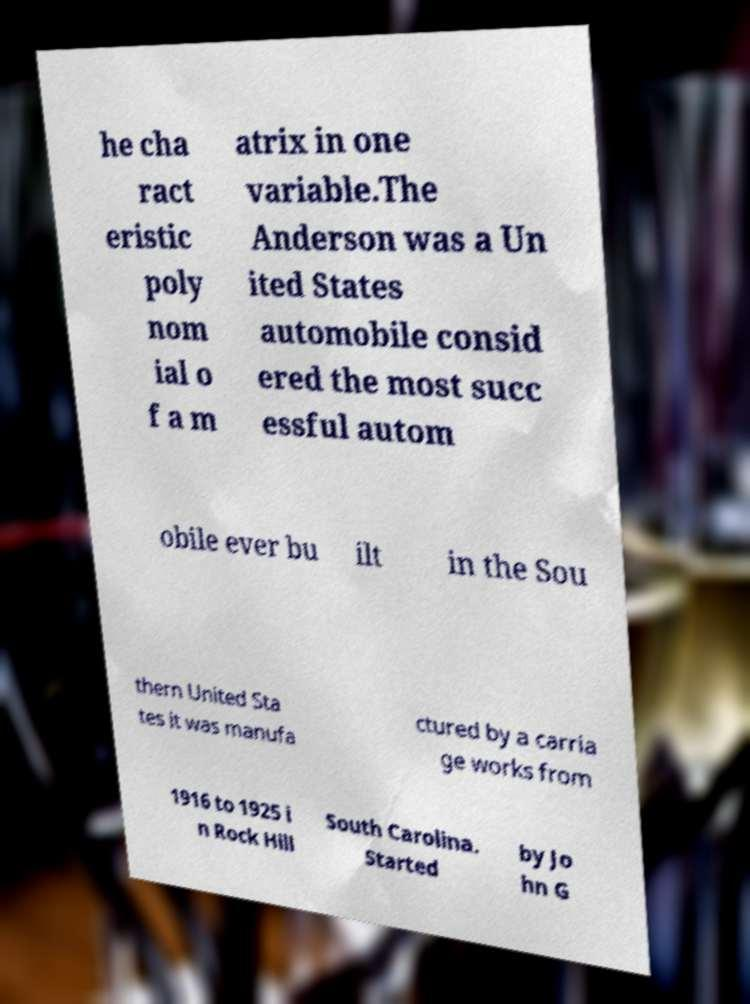Please identify and transcribe the text found in this image. he cha ract eristic poly nom ial o f a m atrix in one variable.The Anderson was a Un ited States automobile consid ered the most succ essful autom obile ever bu ilt in the Sou thern United Sta tes it was manufa ctured by a carria ge works from 1916 to 1925 i n Rock Hill South Carolina. Started by Jo hn G 